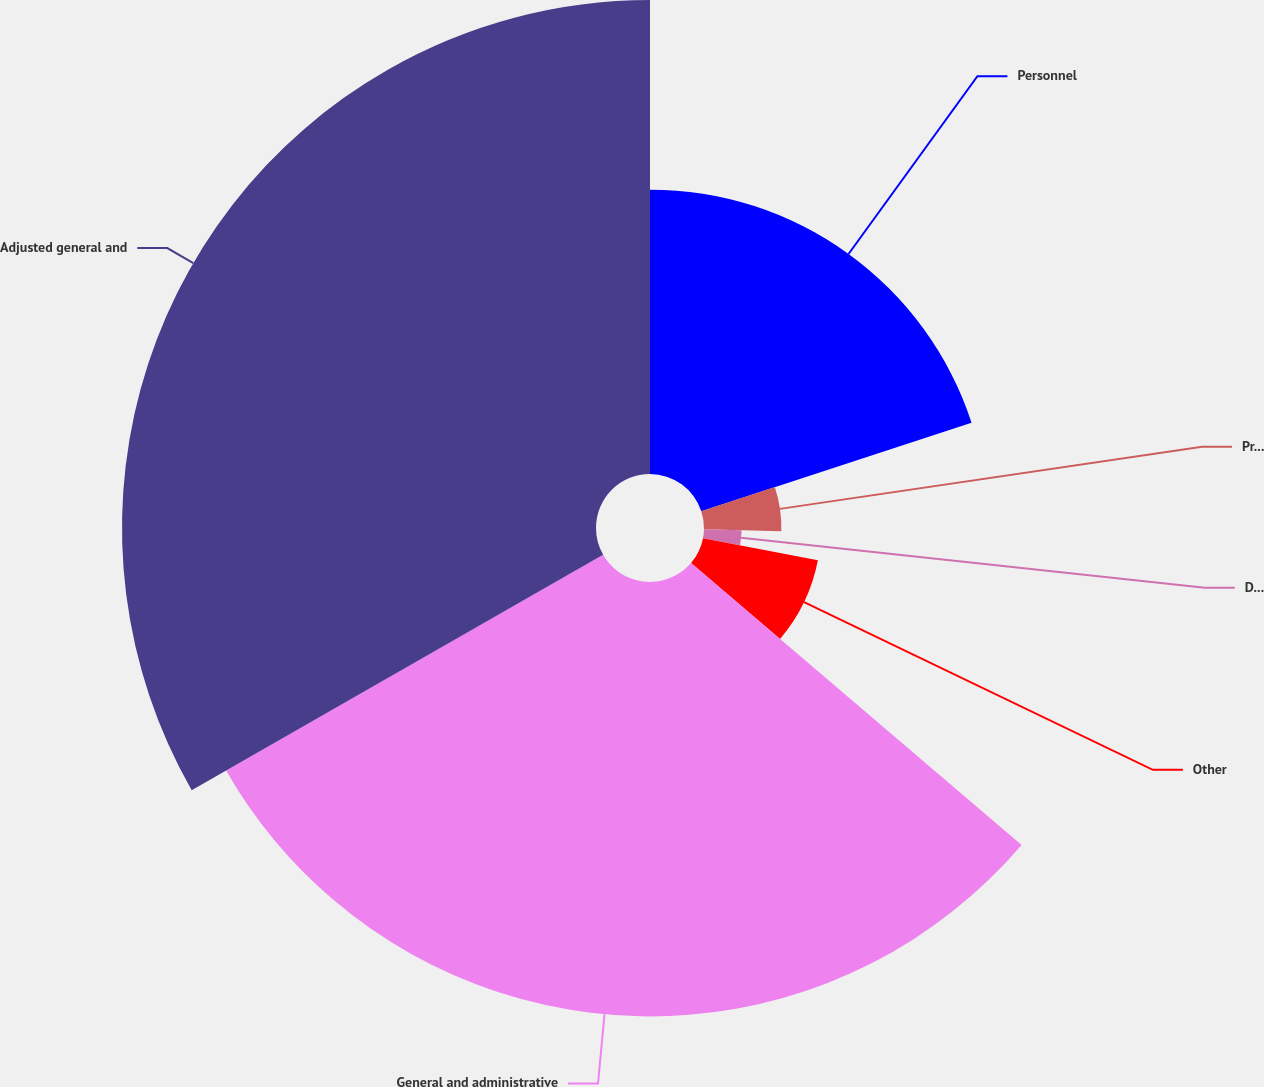Convert chart. <chart><loc_0><loc_0><loc_500><loc_500><pie_chart><fcel>Personnel<fcel>Professional fees<fcel>Data processing and<fcel>Other<fcel>General and administrative<fcel>Adjusted general and<nl><fcel>19.96%<fcel>5.43%<fcel>2.64%<fcel>8.21%<fcel>30.49%<fcel>33.27%<nl></chart> 